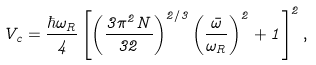<formula> <loc_0><loc_0><loc_500><loc_500>V _ { c } = \frac { \hbar { \omega } _ { R } } { 4 } \left [ \left ( \frac { 3 \pi ^ { 2 } N } { 3 2 } \right ) ^ { 2 / 3 } \left ( \frac { \bar { \omega } } { \omega _ { R } } \right ) ^ { 2 } + 1 \right ] ^ { 2 } ,</formula> 